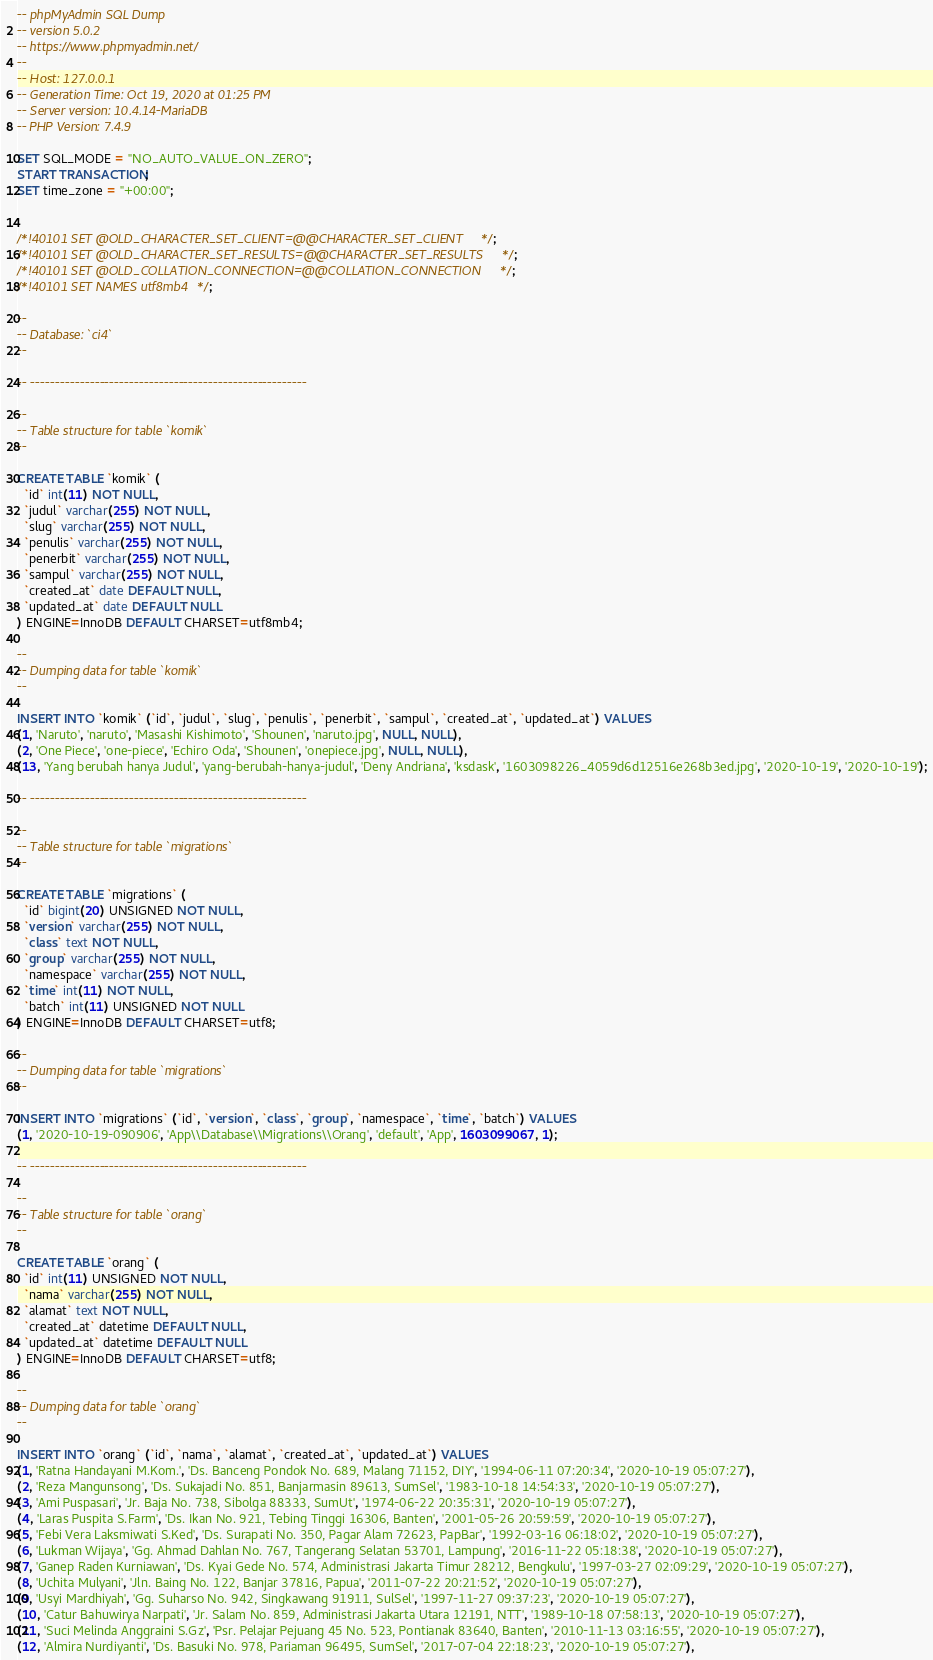<code> <loc_0><loc_0><loc_500><loc_500><_SQL_>-- phpMyAdmin SQL Dump
-- version 5.0.2
-- https://www.phpmyadmin.net/
--
-- Host: 127.0.0.1
-- Generation Time: Oct 19, 2020 at 01:25 PM
-- Server version: 10.4.14-MariaDB
-- PHP Version: 7.4.9

SET SQL_MODE = "NO_AUTO_VALUE_ON_ZERO";
START TRANSACTION;
SET time_zone = "+00:00";


/*!40101 SET @OLD_CHARACTER_SET_CLIENT=@@CHARACTER_SET_CLIENT */;
/*!40101 SET @OLD_CHARACTER_SET_RESULTS=@@CHARACTER_SET_RESULTS */;
/*!40101 SET @OLD_COLLATION_CONNECTION=@@COLLATION_CONNECTION */;
/*!40101 SET NAMES utf8mb4 */;

--
-- Database: `ci4`
--

-- --------------------------------------------------------

--
-- Table structure for table `komik`
--

CREATE TABLE `komik` (
  `id` int(11) NOT NULL,
  `judul` varchar(255) NOT NULL,
  `slug` varchar(255) NOT NULL,
  `penulis` varchar(255) NOT NULL,
  `penerbit` varchar(255) NOT NULL,
  `sampul` varchar(255) NOT NULL,
  `created_at` date DEFAULT NULL,
  `updated_at` date DEFAULT NULL
) ENGINE=InnoDB DEFAULT CHARSET=utf8mb4;

--
-- Dumping data for table `komik`
--

INSERT INTO `komik` (`id`, `judul`, `slug`, `penulis`, `penerbit`, `sampul`, `created_at`, `updated_at`) VALUES
(1, 'Naruto', 'naruto', 'Masashi Kishimoto', 'Shounen', 'naruto.jpg', NULL, NULL),
(2, 'One Piece', 'one-piece', 'Echiro Oda', 'Shounen', 'onepiece.jpg', NULL, NULL),
(13, 'Yang berubah hanya Judul', 'yang-berubah-hanya-judul', 'Deny Andriana', 'ksdask', '1603098226_4059d6d12516e268b3ed.jpg', '2020-10-19', '2020-10-19');

-- --------------------------------------------------------

--
-- Table structure for table `migrations`
--

CREATE TABLE `migrations` (
  `id` bigint(20) UNSIGNED NOT NULL,
  `version` varchar(255) NOT NULL,
  `class` text NOT NULL,
  `group` varchar(255) NOT NULL,
  `namespace` varchar(255) NOT NULL,
  `time` int(11) NOT NULL,
  `batch` int(11) UNSIGNED NOT NULL
) ENGINE=InnoDB DEFAULT CHARSET=utf8;

--
-- Dumping data for table `migrations`
--

INSERT INTO `migrations` (`id`, `version`, `class`, `group`, `namespace`, `time`, `batch`) VALUES
(1, '2020-10-19-090906', 'App\\Database\\Migrations\\Orang', 'default', 'App', 1603099067, 1);

-- --------------------------------------------------------

--
-- Table structure for table `orang`
--

CREATE TABLE `orang` (
  `id` int(11) UNSIGNED NOT NULL,
  `nama` varchar(255) NOT NULL,
  `alamat` text NOT NULL,
  `created_at` datetime DEFAULT NULL,
  `updated_at` datetime DEFAULT NULL
) ENGINE=InnoDB DEFAULT CHARSET=utf8;

--
-- Dumping data for table `orang`
--

INSERT INTO `orang` (`id`, `nama`, `alamat`, `created_at`, `updated_at`) VALUES
(1, 'Ratna Handayani M.Kom.', 'Ds. Banceng Pondok No. 689, Malang 71152, DIY', '1994-06-11 07:20:34', '2020-10-19 05:07:27'),
(2, 'Reza Mangunsong', 'Ds. Sukajadi No. 851, Banjarmasin 89613, SumSel', '1983-10-18 14:54:33', '2020-10-19 05:07:27'),
(3, 'Ami Puspasari', 'Jr. Baja No. 738, Sibolga 88333, SumUt', '1974-06-22 20:35:31', '2020-10-19 05:07:27'),
(4, 'Laras Puspita S.Farm', 'Ds. Ikan No. 921, Tebing Tinggi 16306, Banten', '2001-05-26 20:59:59', '2020-10-19 05:07:27'),
(5, 'Febi Vera Laksmiwati S.Ked', 'Ds. Surapati No. 350, Pagar Alam 72623, PapBar', '1992-03-16 06:18:02', '2020-10-19 05:07:27'),
(6, 'Lukman Wijaya', 'Gg. Ahmad Dahlan No. 767, Tangerang Selatan 53701, Lampung', '2016-11-22 05:18:38', '2020-10-19 05:07:27'),
(7, 'Ganep Raden Kurniawan', 'Ds. Kyai Gede No. 574, Administrasi Jakarta Timur 28212, Bengkulu', '1997-03-27 02:09:29', '2020-10-19 05:07:27'),
(8, 'Uchita Mulyani', 'Jln. Baing No. 122, Banjar 37816, Papua', '2011-07-22 20:21:52', '2020-10-19 05:07:27'),
(9, 'Usyi Mardhiyah', 'Gg. Suharso No. 942, Singkawang 91911, SulSel', '1997-11-27 09:37:23', '2020-10-19 05:07:27'),
(10, 'Catur Bahuwirya Narpati', 'Jr. Salam No. 859, Administrasi Jakarta Utara 12191, NTT', '1989-10-18 07:58:13', '2020-10-19 05:07:27'),
(11, 'Suci Melinda Anggraini S.Gz', 'Psr. Pelajar Pejuang 45 No. 523, Pontianak 83640, Banten', '2010-11-13 03:16:55', '2020-10-19 05:07:27'),
(12, 'Almira Nurdiyanti', 'Ds. Basuki No. 978, Pariaman 96495, SumSel', '2017-07-04 22:18:23', '2020-10-19 05:07:27'),</code> 